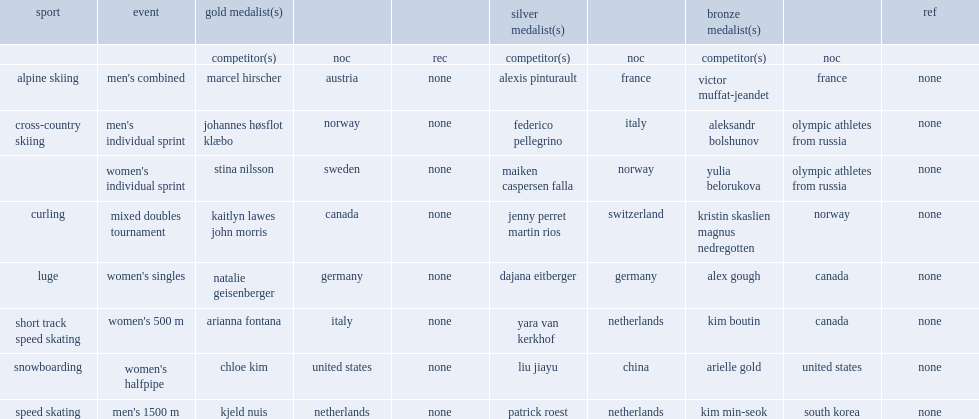Who won the women's singles luge? Natalie geisenberger. 